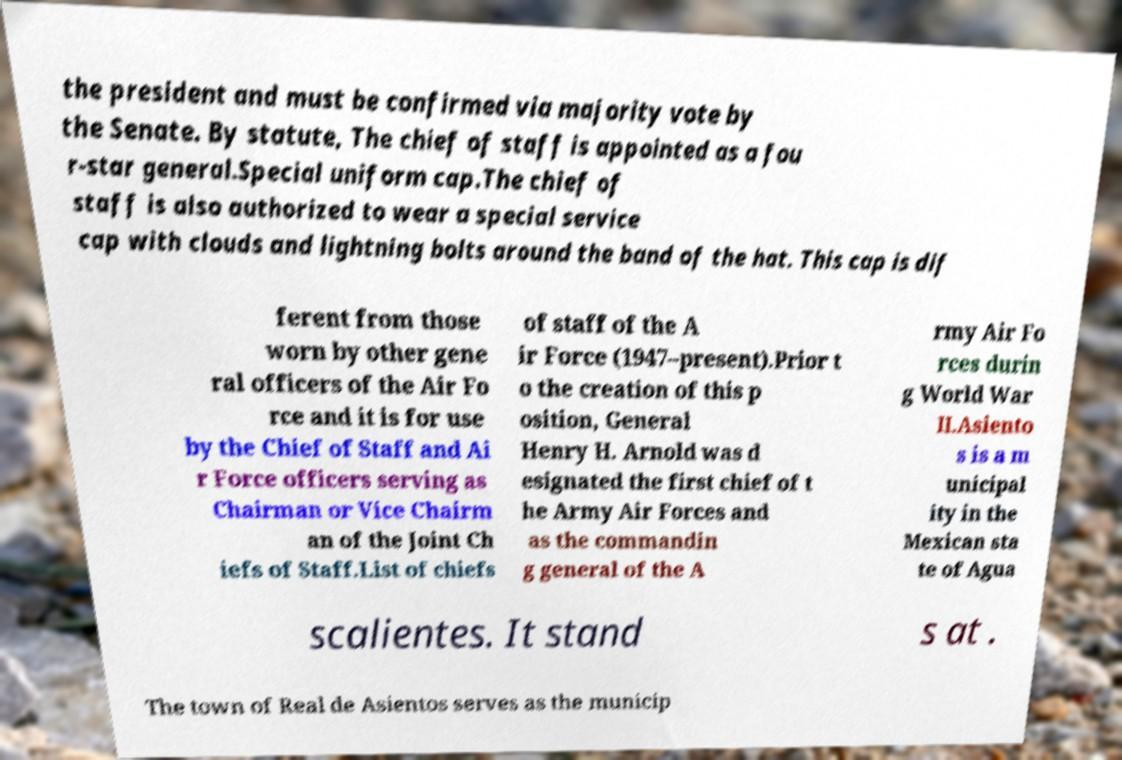Can you read and provide the text displayed in the image?This photo seems to have some interesting text. Can you extract and type it out for me? the president and must be confirmed via majority vote by the Senate. By statute, The chief of staff is appointed as a fou r-star general.Special uniform cap.The chief of staff is also authorized to wear a special service cap with clouds and lightning bolts around the band of the hat. This cap is dif ferent from those worn by other gene ral officers of the Air Fo rce and it is for use by the Chief of Staff and Ai r Force officers serving as Chairman or Vice Chairm an of the Joint Ch iefs of Staff.List of chiefs of staff of the A ir Force (1947–present).Prior t o the creation of this p osition, General Henry H. Arnold was d esignated the first chief of t he Army Air Forces and as the commandin g general of the A rmy Air Fo rces durin g World War II.Asiento s is a m unicipal ity in the Mexican sta te of Agua scalientes. It stand s at . The town of Real de Asientos serves as the municip 